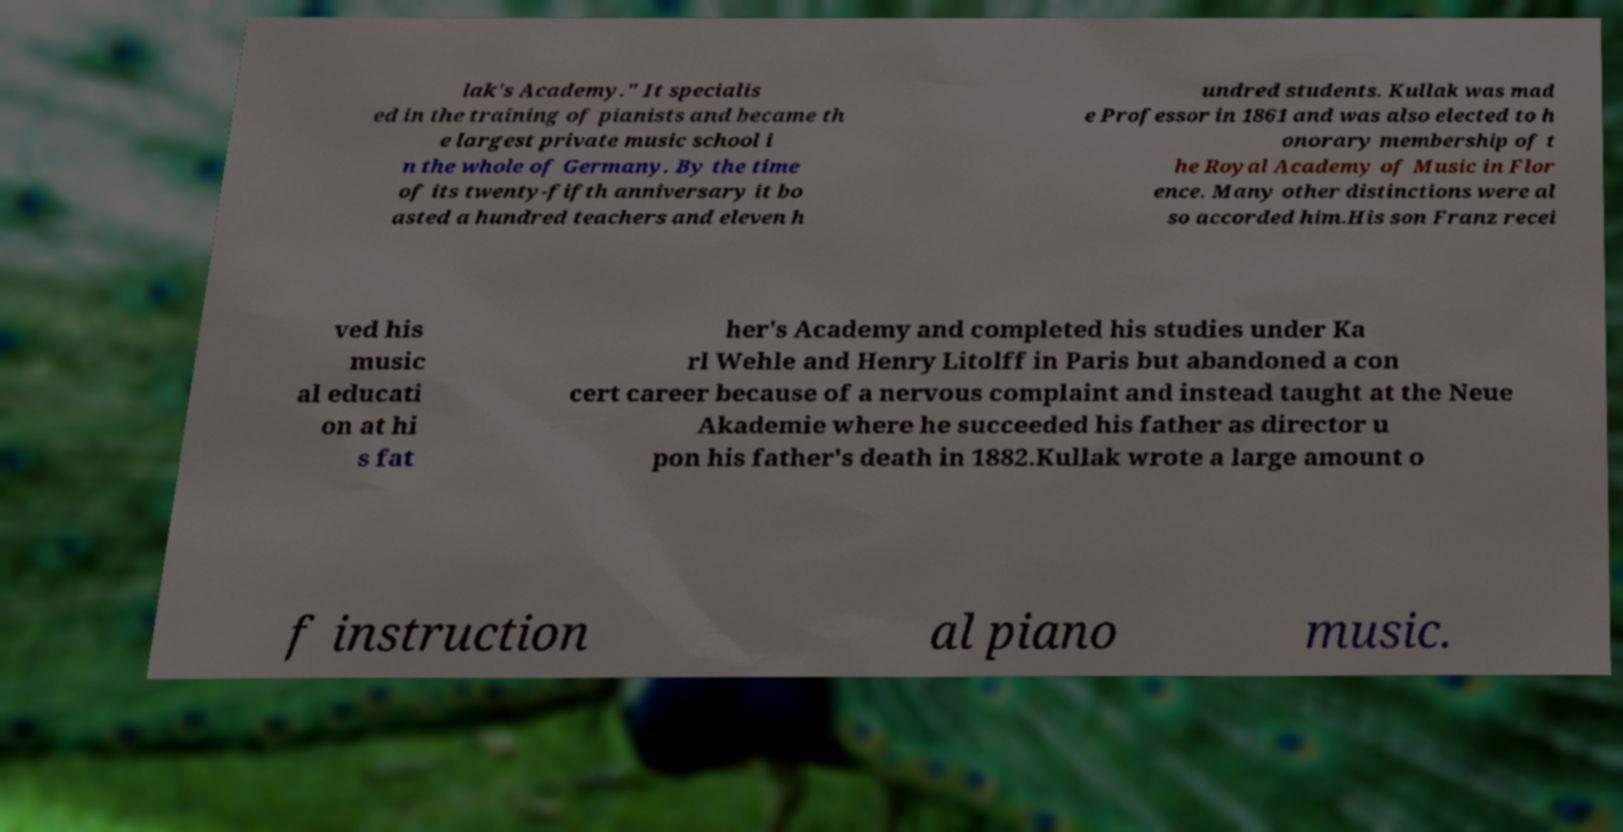Please identify and transcribe the text found in this image. lak's Academy." It specialis ed in the training of pianists and became th e largest private music school i n the whole of Germany. By the time of its twenty-fifth anniversary it bo asted a hundred teachers and eleven h undred students. Kullak was mad e Professor in 1861 and was also elected to h onorary membership of t he Royal Academy of Music in Flor ence. Many other distinctions were al so accorded him.His son Franz recei ved his music al educati on at hi s fat her's Academy and completed his studies under Ka rl Wehle and Henry Litolff in Paris but abandoned a con cert career because of a nervous complaint and instead taught at the Neue Akademie where he succeeded his father as director u pon his father's death in 1882.Kullak wrote a large amount o f instruction al piano music. 